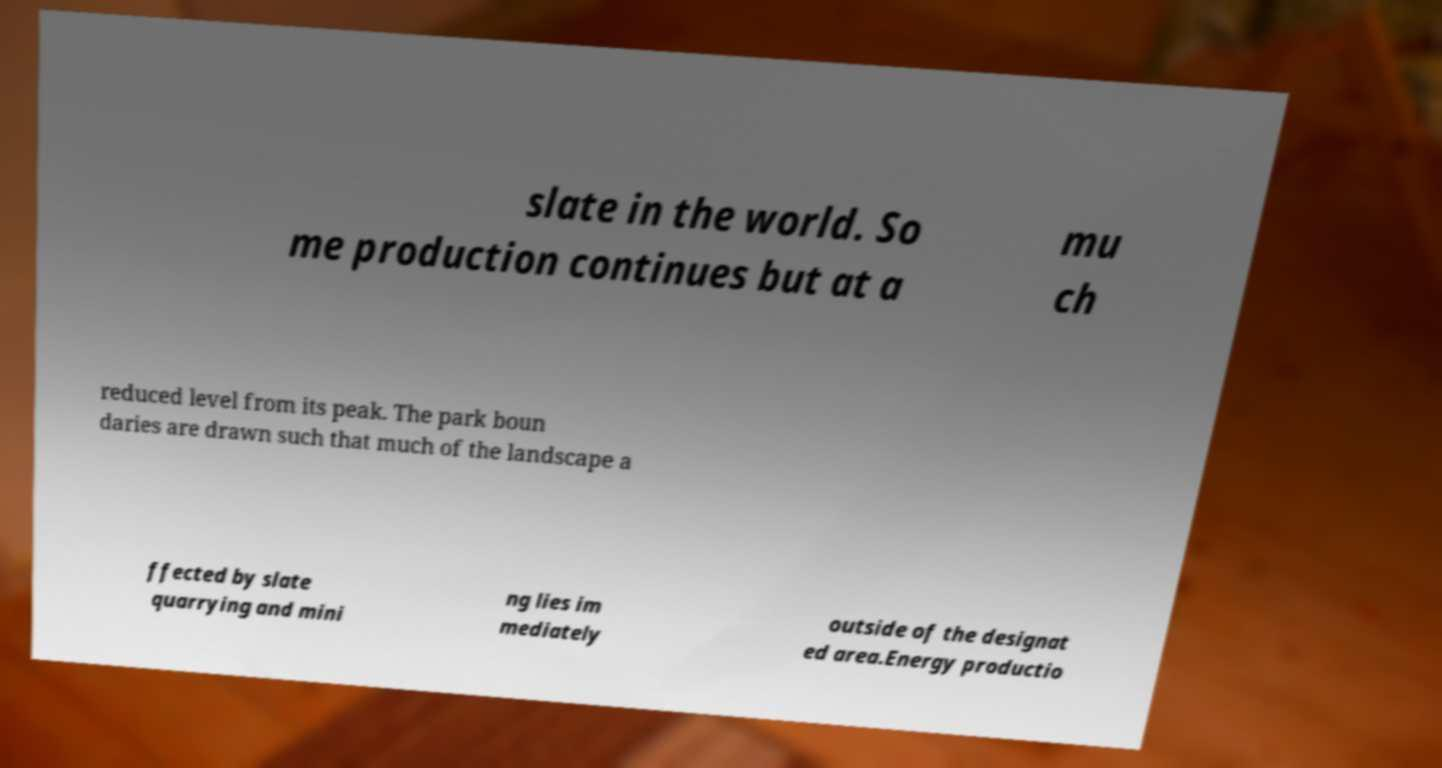Please identify and transcribe the text found in this image. slate in the world. So me production continues but at a mu ch reduced level from its peak. The park boun daries are drawn such that much of the landscape a ffected by slate quarrying and mini ng lies im mediately outside of the designat ed area.Energy productio 